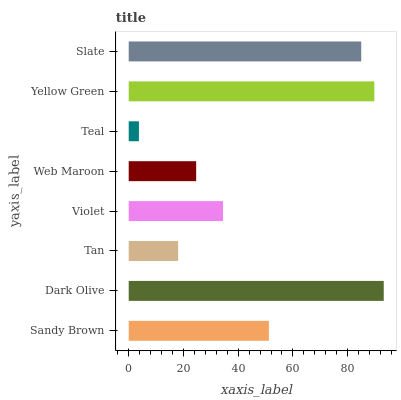Is Teal the minimum?
Answer yes or no. Yes. Is Dark Olive the maximum?
Answer yes or no. Yes. Is Tan the minimum?
Answer yes or no. No. Is Tan the maximum?
Answer yes or no. No. Is Dark Olive greater than Tan?
Answer yes or no. Yes. Is Tan less than Dark Olive?
Answer yes or no. Yes. Is Tan greater than Dark Olive?
Answer yes or no. No. Is Dark Olive less than Tan?
Answer yes or no. No. Is Sandy Brown the high median?
Answer yes or no. Yes. Is Violet the low median?
Answer yes or no. Yes. Is Yellow Green the high median?
Answer yes or no. No. Is Slate the low median?
Answer yes or no. No. 